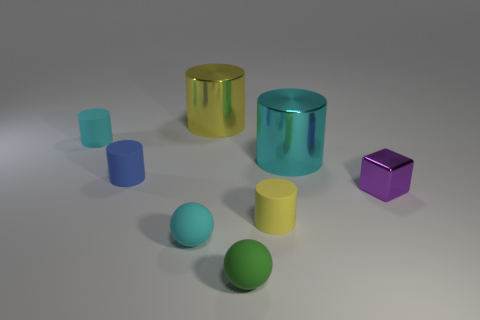How many big things are cyan matte balls or yellow shiny cylinders?
Your answer should be very brief. 1. Are there fewer small yellow matte cylinders than big purple metallic blocks?
Offer a very short reply. No. Is the size of the cyan matte object that is in front of the metallic block the same as the yellow object that is behind the tiny purple cube?
Your answer should be very brief. No. What number of gray things are either large spheres or big metal objects?
Make the answer very short. 0. Are there more small purple metal objects than small red cylinders?
Offer a terse response. Yes. How many things are either cylinders or big objects in front of the big yellow shiny object?
Give a very brief answer. 5. What number of other things are there of the same shape as the blue rubber object?
Make the answer very short. 4. Are there fewer yellow matte objects that are behind the big yellow shiny object than matte cylinders that are on the right side of the green rubber object?
Ensure brevity in your answer.  Yes. What is the shape of the large object that is the same material as the large yellow cylinder?
Keep it short and to the point. Cylinder. What color is the tiny thing behind the cyan cylinder on the right side of the tiny yellow matte cylinder?
Offer a very short reply. Cyan. 